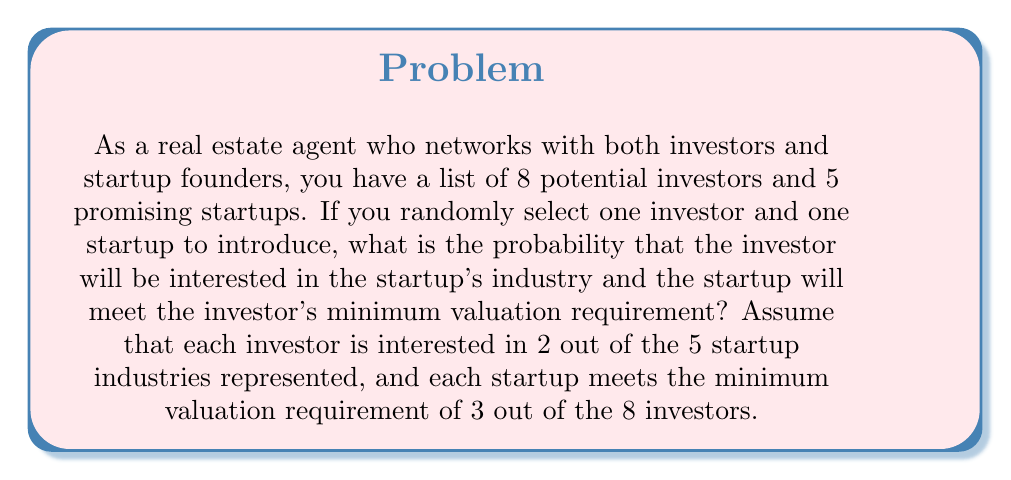Show me your answer to this math problem. Let's approach this step-by-step:

1) First, we need to calculate the probability that a randomly selected investor will be interested in a randomly selected startup's industry:
   - Each investor is interested in 2 out of 5 industries
   - Probability = $\frac{2}{5}$

2) Next, we calculate the probability that a randomly selected startup meets the minimum valuation requirement of a randomly selected investor:
   - Each startup meets the requirements of 3 out of 8 investors
   - Probability = $\frac{3}{8}$

3) For a successful connection, both events need to occur independently. We multiply these probabilities:

   $P(\text{successful connection}) = P(\text{investor interest}) \times P(\text{startup meets valuation})$

   $P(\text{successful connection}) = \frac{2}{5} \times \frac{3}{8}$

4) Simplifying the fraction:

   $P(\text{successful connection}) = \frac{6}{40} = \frac{3}{20}$

Therefore, the probability of successfully connecting an investor with a startup under these conditions is $\frac{3}{20}$ or 0.15 or 15%.
Answer: $\frac{3}{20}$ 